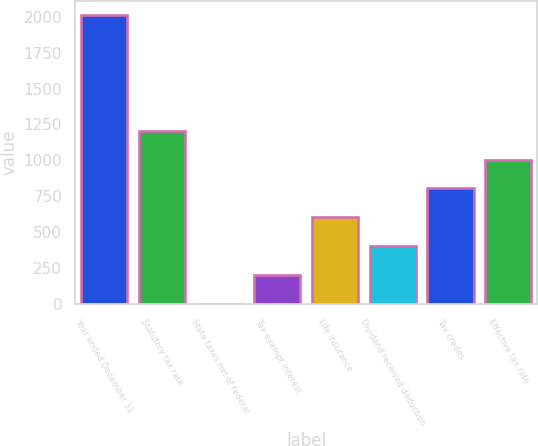Convert chart. <chart><loc_0><loc_0><loc_500><loc_500><bar_chart><fcel>Year ended December 31<fcel>Statutory tax rate<fcel>State taxes net of federal<fcel>Tax-exempt interest<fcel>Life insurance<fcel>Dividend received deduction<fcel>Tax credits<fcel>Effective tax rate<nl><fcel>2009<fcel>1205.88<fcel>1.2<fcel>201.98<fcel>603.54<fcel>402.76<fcel>804.32<fcel>1005.1<nl></chart> 